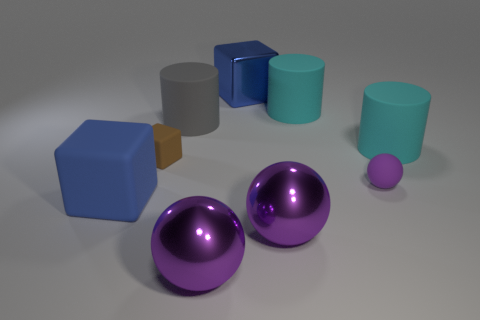Is the color of the tiny matte ball the same as the large metal sphere left of the blue metal block?
Your response must be concise. Yes. What is the color of the rubber cube that is the same size as the gray cylinder?
Keep it short and to the point. Blue. Are the tiny purple object and the large gray cylinder made of the same material?
Your answer should be compact. Yes. What number of other cubes are the same color as the small matte cube?
Offer a terse response. 0. Is the metal block the same color as the big matte block?
Give a very brief answer. Yes. What is the material of the cube behind the gray object?
Your answer should be very brief. Metal. How many small things are cylinders or blue metal cubes?
Ensure brevity in your answer.  0. What material is the other block that is the same color as the big matte block?
Ensure brevity in your answer.  Metal. Are there any cubes that have the same material as the big gray cylinder?
Keep it short and to the point. Yes. There is a blue rubber thing in front of the gray matte thing; does it have the same size as the gray cylinder?
Your answer should be compact. Yes. 